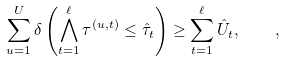Convert formula to latex. <formula><loc_0><loc_0><loc_500><loc_500>\sum _ { u = 1 } ^ { U } \delta \left ( \bigwedge _ { t = 1 } ^ { \ell } \tau ^ { ( u , t ) } \leq \hat { \tau } _ { t } \right ) \geq \sum _ { t = 1 } ^ { \ell } \hat { U } _ { t } , \quad ,</formula> 